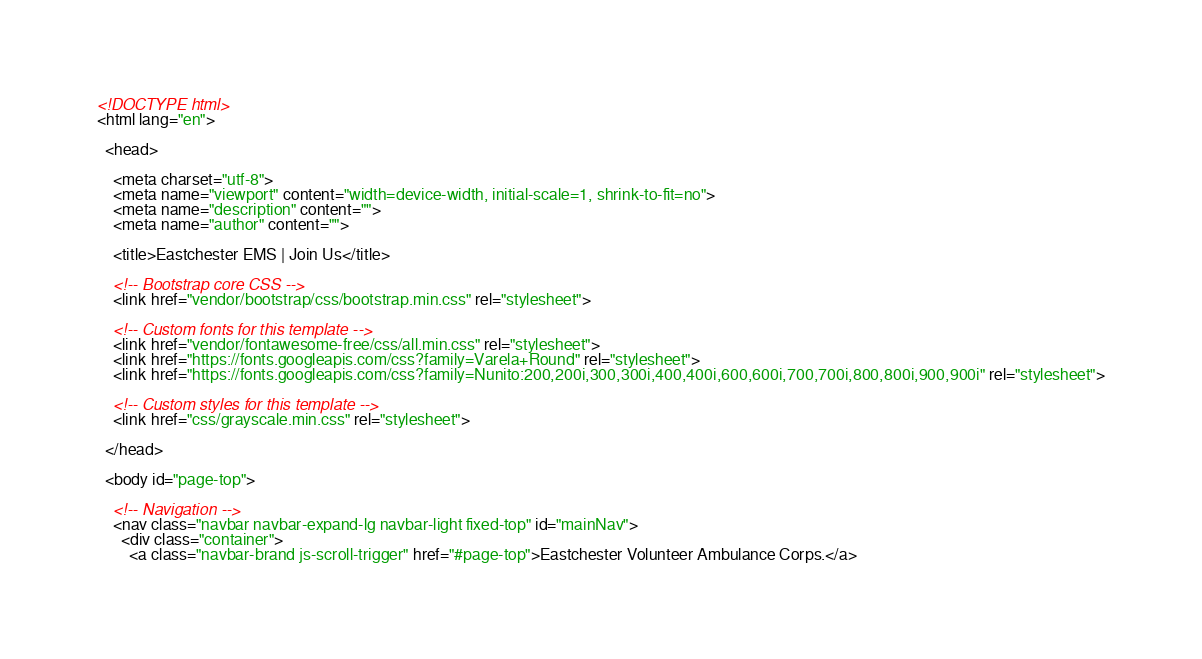<code> <loc_0><loc_0><loc_500><loc_500><_HTML_><!DOCTYPE html>
<html lang="en">

  <head>

    <meta charset="utf-8">
    <meta name="viewport" content="width=device-width, initial-scale=1, shrink-to-fit=no">
    <meta name="description" content="">
    <meta name="author" content="">

    <title>Eastchester EMS | Join Us</title>

    <!-- Bootstrap core CSS -->
    <link href="vendor/bootstrap/css/bootstrap.min.css" rel="stylesheet">

    <!-- Custom fonts for this template -->
    <link href="vendor/fontawesome-free/css/all.min.css" rel="stylesheet">
    <link href="https://fonts.googleapis.com/css?family=Varela+Round" rel="stylesheet">
    <link href="https://fonts.googleapis.com/css?family=Nunito:200,200i,300,300i,400,400i,600,600i,700,700i,800,800i,900,900i" rel="stylesheet">

    <!-- Custom styles for this template -->
    <link href="css/grayscale.min.css" rel="stylesheet">

  </head>

  <body id="page-top">

    <!-- Navigation -->
    <nav class="navbar navbar-expand-lg navbar-light fixed-top" id="mainNav">
      <div class="container">
        <a class="navbar-brand js-scroll-trigger" href="#page-top">Eastchester Volunteer Ambulance Corps.</a></code> 